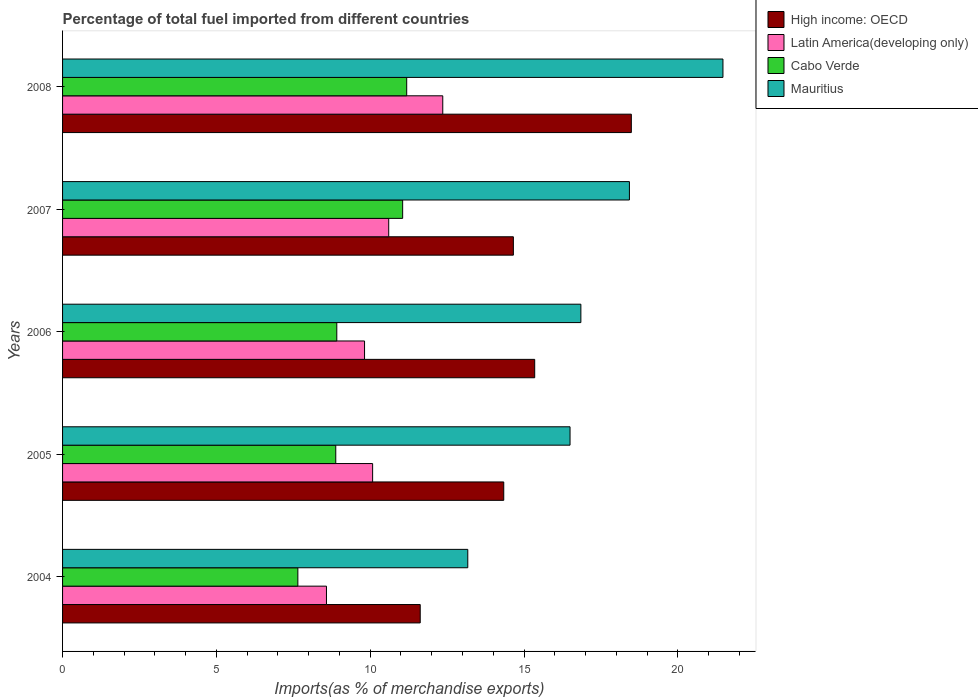How many different coloured bars are there?
Your response must be concise. 4. How many groups of bars are there?
Your response must be concise. 5. Are the number of bars per tick equal to the number of legend labels?
Offer a terse response. Yes. How many bars are there on the 3rd tick from the top?
Keep it short and to the point. 4. How many bars are there on the 1st tick from the bottom?
Your answer should be compact. 4. In how many cases, is the number of bars for a given year not equal to the number of legend labels?
Your answer should be very brief. 0. What is the percentage of imports to different countries in High income: OECD in 2008?
Make the answer very short. 18.49. Across all years, what is the maximum percentage of imports to different countries in Cabo Verde?
Provide a succinct answer. 11.19. Across all years, what is the minimum percentage of imports to different countries in Latin America(developing only)?
Offer a terse response. 8.58. In which year was the percentage of imports to different countries in Mauritius maximum?
Offer a terse response. 2008. What is the total percentage of imports to different countries in Latin America(developing only) in the graph?
Provide a succinct answer. 51.43. What is the difference between the percentage of imports to different countries in High income: OECD in 2006 and that in 2008?
Your answer should be compact. -3.14. What is the difference between the percentage of imports to different countries in Mauritius in 2006 and the percentage of imports to different countries in Cabo Verde in 2005?
Offer a terse response. 7.97. What is the average percentage of imports to different countries in Cabo Verde per year?
Offer a very short reply. 9.54. In the year 2007, what is the difference between the percentage of imports to different countries in High income: OECD and percentage of imports to different countries in Cabo Verde?
Your answer should be very brief. 3.6. What is the ratio of the percentage of imports to different countries in Mauritius in 2004 to that in 2005?
Your response must be concise. 0.8. What is the difference between the highest and the second highest percentage of imports to different countries in High income: OECD?
Provide a short and direct response. 3.14. What is the difference between the highest and the lowest percentage of imports to different countries in Mauritius?
Your answer should be very brief. 8.29. In how many years, is the percentage of imports to different countries in Cabo Verde greater than the average percentage of imports to different countries in Cabo Verde taken over all years?
Provide a short and direct response. 2. Is the sum of the percentage of imports to different countries in Cabo Verde in 2004 and 2007 greater than the maximum percentage of imports to different countries in Latin America(developing only) across all years?
Provide a succinct answer. Yes. Is it the case that in every year, the sum of the percentage of imports to different countries in High income: OECD and percentage of imports to different countries in Mauritius is greater than the sum of percentage of imports to different countries in Latin America(developing only) and percentage of imports to different countries in Cabo Verde?
Provide a short and direct response. Yes. What does the 4th bar from the top in 2006 represents?
Give a very brief answer. High income: OECD. What does the 4th bar from the bottom in 2006 represents?
Provide a short and direct response. Mauritius. How many bars are there?
Ensure brevity in your answer.  20. What is the difference between two consecutive major ticks on the X-axis?
Provide a succinct answer. 5. Are the values on the major ticks of X-axis written in scientific E-notation?
Your response must be concise. No. Does the graph contain any zero values?
Your answer should be very brief. No. Does the graph contain grids?
Keep it short and to the point. No. Where does the legend appear in the graph?
Make the answer very short. Top right. What is the title of the graph?
Your answer should be compact. Percentage of total fuel imported from different countries. What is the label or title of the X-axis?
Your answer should be compact. Imports(as % of merchandise exports). What is the label or title of the Y-axis?
Make the answer very short. Years. What is the Imports(as % of merchandise exports) of High income: OECD in 2004?
Your answer should be very brief. 11.63. What is the Imports(as % of merchandise exports) of Latin America(developing only) in 2004?
Provide a succinct answer. 8.58. What is the Imports(as % of merchandise exports) in Cabo Verde in 2004?
Give a very brief answer. 7.65. What is the Imports(as % of merchandise exports) in Mauritius in 2004?
Keep it short and to the point. 13.17. What is the Imports(as % of merchandise exports) of High income: OECD in 2005?
Your answer should be very brief. 14.34. What is the Imports(as % of merchandise exports) in Latin America(developing only) in 2005?
Provide a short and direct response. 10.08. What is the Imports(as % of merchandise exports) in Cabo Verde in 2005?
Keep it short and to the point. 8.88. What is the Imports(as % of merchandise exports) of Mauritius in 2005?
Your answer should be very brief. 16.5. What is the Imports(as % of merchandise exports) of High income: OECD in 2006?
Your response must be concise. 15.35. What is the Imports(as % of merchandise exports) in Latin America(developing only) in 2006?
Offer a very short reply. 9.82. What is the Imports(as % of merchandise exports) in Cabo Verde in 2006?
Ensure brevity in your answer.  8.91. What is the Imports(as % of merchandise exports) of Mauritius in 2006?
Your answer should be compact. 16.85. What is the Imports(as % of merchandise exports) in High income: OECD in 2007?
Your answer should be compact. 14.65. What is the Imports(as % of merchandise exports) of Latin America(developing only) in 2007?
Provide a short and direct response. 10.6. What is the Imports(as % of merchandise exports) of Cabo Verde in 2007?
Your answer should be very brief. 11.05. What is the Imports(as % of merchandise exports) in Mauritius in 2007?
Give a very brief answer. 18.43. What is the Imports(as % of merchandise exports) in High income: OECD in 2008?
Your answer should be very brief. 18.49. What is the Imports(as % of merchandise exports) of Latin America(developing only) in 2008?
Offer a terse response. 12.36. What is the Imports(as % of merchandise exports) in Cabo Verde in 2008?
Your answer should be compact. 11.19. What is the Imports(as % of merchandise exports) of Mauritius in 2008?
Provide a succinct answer. 21.47. Across all years, what is the maximum Imports(as % of merchandise exports) in High income: OECD?
Your answer should be compact. 18.49. Across all years, what is the maximum Imports(as % of merchandise exports) in Latin America(developing only)?
Ensure brevity in your answer.  12.36. Across all years, what is the maximum Imports(as % of merchandise exports) in Cabo Verde?
Offer a terse response. 11.19. Across all years, what is the maximum Imports(as % of merchandise exports) in Mauritius?
Provide a succinct answer. 21.47. Across all years, what is the minimum Imports(as % of merchandise exports) of High income: OECD?
Your answer should be compact. 11.63. Across all years, what is the minimum Imports(as % of merchandise exports) of Latin America(developing only)?
Provide a succinct answer. 8.58. Across all years, what is the minimum Imports(as % of merchandise exports) of Cabo Verde?
Make the answer very short. 7.65. Across all years, what is the minimum Imports(as % of merchandise exports) in Mauritius?
Give a very brief answer. 13.17. What is the total Imports(as % of merchandise exports) in High income: OECD in the graph?
Offer a terse response. 74.45. What is the total Imports(as % of merchandise exports) of Latin America(developing only) in the graph?
Your answer should be very brief. 51.43. What is the total Imports(as % of merchandise exports) in Cabo Verde in the graph?
Offer a terse response. 47.68. What is the total Imports(as % of merchandise exports) of Mauritius in the graph?
Offer a very short reply. 86.41. What is the difference between the Imports(as % of merchandise exports) of High income: OECD in 2004 and that in 2005?
Ensure brevity in your answer.  -2.71. What is the difference between the Imports(as % of merchandise exports) of Latin America(developing only) in 2004 and that in 2005?
Ensure brevity in your answer.  -1.5. What is the difference between the Imports(as % of merchandise exports) of Cabo Verde in 2004 and that in 2005?
Your answer should be compact. -1.23. What is the difference between the Imports(as % of merchandise exports) in Mauritius in 2004 and that in 2005?
Ensure brevity in your answer.  -3.32. What is the difference between the Imports(as % of merchandise exports) of High income: OECD in 2004 and that in 2006?
Offer a terse response. -3.72. What is the difference between the Imports(as % of merchandise exports) in Latin America(developing only) in 2004 and that in 2006?
Offer a very short reply. -1.24. What is the difference between the Imports(as % of merchandise exports) in Cabo Verde in 2004 and that in 2006?
Make the answer very short. -1.27. What is the difference between the Imports(as % of merchandise exports) in Mauritius in 2004 and that in 2006?
Your answer should be compact. -3.68. What is the difference between the Imports(as % of merchandise exports) in High income: OECD in 2004 and that in 2007?
Provide a succinct answer. -3.03. What is the difference between the Imports(as % of merchandise exports) in Latin America(developing only) in 2004 and that in 2007?
Provide a short and direct response. -2.02. What is the difference between the Imports(as % of merchandise exports) in Cabo Verde in 2004 and that in 2007?
Offer a terse response. -3.41. What is the difference between the Imports(as % of merchandise exports) of Mauritius in 2004 and that in 2007?
Your answer should be very brief. -5.25. What is the difference between the Imports(as % of merchandise exports) of High income: OECD in 2004 and that in 2008?
Offer a very short reply. -6.86. What is the difference between the Imports(as % of merchandise exports) of Latin America(developing only) in 2004 and that in 2008?
Provide a succinct answer. -3.78. What is the difference between the Imports(as % of merchandise exports) in Cabo Verde in 2004 and that in 2008?
Keep it short and to the point. -3.54. What is the difference between the Imports(as % of merchandise exports) in Mauritius in 2004 and that in 2008?
Make the answer very short. -8.29. What is the difference between the Imports(as % of merchandise exports) in High income: OECD in 2005 and that in 2006?
Give a very brief answer. -1.01. What is the difference between the Imports(as % of merchandise exports) in Latin America(developing only) in 2005 and that in 2006?
Offer a terse response. 0.26. What is the difference between the Imports(as % of merchandise exports) in Cabo Verde in 2005 and that in 2006?
Make the answer very short. -0.03. What is the difference between the Imports(as % of merchandise exports) of Mauritius in 2005 and that in 2006?
Give a very brief answer. -0.35. What is the difference between the Imports(as % of merchandise exports) in High income: OECD in 2005 and that in 2007?
Provide a succinct answer. -0.31. What is the difference between the Imports(as % of merchandise exports) of Latin America(developing only) in 2005 and that in 2007?
Your answer should be compact. -0.52. What is the difference between the Imports(as % of merchandise exports) in Cabo Verde in 2005 and that in 2007?
Your answer should be very brief. -2.17. What is the difference between the Imports(as % of merchandise exports) in Mauritius in 2005 and that in 2007?
Provide a succinct answer. -1.93. What is the difference between the Imports(as % of merchandise exports) in High income: OECD in 2005 and that in 2008?
Give a very brief answer. -4.15. What is the difference between the Imports(as % of merchandise exports) in Latin America(developing only) in 2005 and that in 2008?
Provide a succinct answer. -2.28. What is the difference between the Imports(as % of merchandise exports) in Cabo Verde in 2005 and that in 2008?
Ensure brevity in your answer.  -2.31. What is the difference between the Imports(as % of merchandise exports) in Mauritius in 2005 and that in 2008?
Give a very brief answer. -4.97. What is the difference between the Imports(as % of merchandise exports) of High income: OECD in 2006 and that in 2007?
Offer a very short reply. 0.69. What is the difference between the Imports(as % of merchandise exports) of Latin America(developing only) in 2006 and that in 2007?
Offer a very short reply. -0.79. What is the difference between the Imports(as % of merchandise exports) of Cabo Verde in 2006 and that in 2007?
Give a very brief answer. -2.14. What is the difference between the Imports(as % of merchandise exports) in Mauritius in 2006 and that in 2007?
Make the answer very short. -1.58. What is the difference between the Imports(as % of merchandise exports) of High income: OECD in 2006 and that in 2008?
Provide a succinct answer. -3.14. What is the difference between the Imports(as % of merchandise exports) of Latin America(developing only) in 2006 and that in 2008?
Your answer should be compact. -2.54. What is the difference between the Imports(as % of merchandise exports) in Cabo Verde in 2006 and that in 2008?
Make the answer very short. -2.27. What is the difference between the Imports(as % of merchandise exports) of Mauritius in 2006 and that in 2008?
Make the answer very short. -4.62. What is the difference between the Imports(as % of merchandise exports) in High income: OECD in 2007 and that in 2008?
Provide a succinct answer. -3.83. What is the difference between the Imports(as % of merchandise exports) in Latin America(developing only) in 2007 and that in 2008?
Your answer should be compact. -1.76. What is the difference between the Imports(as % of merchandise exports) in Cabo Verde in 2007 and that in 2008?
Offer a terse response. -0.13. What is the difference between the Imports(as % of merchandise exports) in Mauritius in 2007 and that in 2008?
Provide a short and direct response. -3.04. What is the difference between the Imports(as % of merchandise exports) in High income: OECD in 2004 and the Imports(as % of merchandise exports) in Latin America(developing only) in 2005?
Give a very brief answer. 1.55. What is the difference between the Imports(as % of merchandise exports) of High income: OECD in 2004 and the Imports(as % of merchandise exports) of Cabo Verde in 2005?
Provide a succinct answer. 2.75. What is the difference between the Imports(as % of merchandise exports) of High income: OECD in 2004 and the Imports(as % of merchandise exports) of Mauritius in 2005?
Offer a very short reply. -4.87. What is the difference between the Imports(as % of merchandise exports) in Latin America(developing only) in 2004 and the Imports(as % of merchandise exports) in Cabo Verde in 2005?
Ensure brevity in your answer.  -0.3. What is the difference between the Imports(as % of merchandise exports) of Latin America(developing only) in 2004 and the Imports(as % of merchandise exports) of Mauritius in 2005?
Your answer should be very brief. -7.92. What is the difference between the Imports(as % of merchandise exports) of Cabo Verde in 2004 and the Imports(as % of merchandise exports) of Mauritius in 2005?
Your answer should be very brief. -8.85. What is the difference between the Imports(as % of merchandise exports) in High income: OECD in 2004 and the Imports(as % of merchandise exports) in Latin America(developing only) in 2006?
Ensure brevity in your answer.  1.81. What is the difference between the Imports(as % of merchandise exports) of High income: OECD in 2004 and the Imports(as % of merchandise exports) of Cabo Verde in 2006?
Offer a terse response. 2.71. What is the difference between the Imports(as % of merchandise exports) of High income: OECD in 2004 and the Imports(as % of merchandise exports) of Mauritius in 2006?
Your answer should be compact. -5.22. What is the difference between the Imports(as % of merchandise exports) in Latin America(developing only) in 2004 and the Imports(as % of merchandise exports) in Cabo Verde in 2006?
Your answer should be very brief. -0.34. What is the difference between the Imports(as % of merchandise exports) of Latin America(developing only) in 2004 and the Imports(as % of merchandise exports) of Mauritius in 2006?
Your answer should be very brief. -8.27. What is the difference between the Imports(as % of merchandise exports) of Cabo Verde in 2004 and the Imports(as % of merchandise exports) of Mauritius in 2006?
Ensure brevity in your answer.  -9.2. What is the difference between the Imports(as % of merchandise exports) in High income: OECD in 2004 and the Imports(as % of merchandise exports) in Latin America(developing only) in 2007?
Your answer should be compact. 1.02. What is the difference between the Imports(as % of merchandise exports) of High income: OECD in 2004 and the Imports(as % of merchandise exports) of Cabo Verde in 2007?
Ensure brevity in your answer.  0.57. What is the difference between the Imports(as % of merchandise exports) of High income: OECD in 2004 and the Imports(as % of merchandise exports) of Mauritius in 2007?
Your answer should be compact. -6.8. What is the difference between the Imports(as % of merchandise exports) of Latin America(developing only) in 2004 and the Imports(as % of merchandise exports) of Cabo Verde in 2007?
Offer a terse response. -2.48. What is the difference between the Imports(as % of merchandise exports) in Latin America(developing only) in 2004 and the Imports(as % of merchandise exports) in Mauritius in 2007?
Provide a short and direct response. -9.85. What is the difference between the Imports(as % of merchandise exports) in Cabo Verde in 2004 and the Imports(as % of merchandise exports) in Mauritius in 2007?
Keep it short and to the point. -10.78. What is the difference between the Imports(as % of merchandise exports) in High income: OECD in 2004 and the Imports(as % of merchandise exports) in Latin America(developing only) in 2008?
Ensure brevity in your answer.  -0.73. What is the difference between the Imports(as % of merchandise exports) of High income: OECD in 2004 and the Imports(as % of merchandise exports) of Cabo Verde in 2008?
Offer a terse response. 0.44. What is the difference between the Imports(as % of merchandise exports) in High income: OECD in 2004 and the Imports(as % of merchandise exports) in Mauritius in 2008?
Ensure brevity in your answer.  -9.84. What is the difference between the Imports(as % of merchandise exports) of Latin America(developing only) in 2004 and the Imports(as % of merchandise exports) of Cabo Verde in 2008?
Keep it short and to the point. -2.61. What is the difference between the Imports(as % of merchandise exports) of Latin America(developing only) in 2004 and the Imports(as % of merchandise exports) of Mauritius in 2008?
Your response must be concise. -12.89. What is the difference between the Imports(as % of merchandise exports) in Cabo Verde in 2004 and the Imports(as % of merchandise exports) in Mauritius in 2008?
Provide a succinct answer. -13.82. What is the difference between the Imports(as % of merchandise exports) of High income: OECD in 2005 and the Imports(as % of merchandise exports) of Latin America(developing only) in 2006?
Offer a terse response. 4.52. What is the difference between the Imports(as % of merchandise exports) in High income: OECD in 2005 and the Imports(as % of merchandise exports) in Cabo Verde in 2006?
Your answer should be compact. 5.43. What is the difference between the Imports(as % of merchandise exports) of High income: OECD in 2005 and the Imports(as % of merchandise exports) of Mauritius in 2006?
Keep it short and to the point. -2.51. What is the difference between the Imports(as % of merchandise exports) of Latin America(developing only) in 2005 and the Imports(as % of merchandise exports) of Cabo Verde in 2006?
Provide a succinct answer. 1.16. What is the difference between the Imports(as % of merchandise exports) of Latin America(developing only) in 2005 and the Imports(as % of merchandise exports) of Mauritius in 2006?
Keep it short and to the point. -6.77. What is the difference between the Imports(as % of merchandise exports) in Cabo Verde in 2005 and the Imports(as % of merchandise exports) in Mauritius in 2006?
Your response must be concise. -7.97. What is the difference between the Imports(as % of merchandise exports) of High income: OECD in 2005 and the Imports(as % of merchandise exports) of Latin America(developing only) in 2007?
Your response must be concise. 3.74. What is the difference between the Imports(as % of merchandise exports) of High income: OECD in 2005 and the Imports(as % of merchandise exports) of Cabo Verde in 2007?
Offer a terse response. 3.29. What is the difference between the Imports(as % of merchandise exports) of High income: OECD in 2005 and the Imports(as % of merchandise exports) of Mauritius in 2007?
Keep it short and to the point. -4.08. What is the difference between the Imports(as % of merchandise exports) of Latin America(developing only) in 2005 and the Imports(as % of merchandise exports) of Cabo Verde in 2007?
Offer a terse response. -0.98. What is the difference between the Imports(as % of merchandise exports) in Latin America(developing only) in 2005 and the Imports(as % of merchandise exports) in Mauritius in 2007?
Ensure brevity in your answer.  -8.35. What is the difference between the Imports(as % of merchandise exports) in Cabo Verde in 2005 and the Imports(as % of merchandise exports) in Mauritius in 2007?
Your answer should be compact. -9.55. What is the difference between the Imports(as % of merchandise exports) in High income: OECD in 2005 and the Imports(as % of merchandise exports) in Latin America(developing only) in 2008?
Offer a terse response. 1.98. What is the difference between the Imports(as % of merchandise exports) in High income: OECD in 2005 and the Imports(as % of merchandise exports) in Cabo Verde in 2008?
Your response must be concise. 3.15. What is the difference between the Imports(as % of merchandise exports) in High income: OECD in 2005 and the Imports(as % of merchandise exports) in Mauritius in 2008?
Your answer should be compact. -7.13. What is the difference between the Imports(as % of merchandise exports) in Latin America(developing only) in 2005 and the Imports(as % of merchandise exports) in Cabo Verde in 2008?
Your response must be concise. -1.11. What is the difference between the Imports(as % of merchandise exports) of Latin America(developing only) in 2005 and the Imports(as % of merchandise exports) of Mauritius in 2008?
Offer a terse response. -11.39. What is the difference between the Imports(as % of merchandise exports) in Cabo Verde in 2005 and the Imports(as % of merchandise exports) in Mauritius in 2008?
Provide a succinct answer. -12.59. What is the difference between the Imports(as % of merchandise exports) of High income: OECD in 2006 and the Imports(as % of merchandise exports) of Latin America(developing only) in 2007?
Provide a succinct answer. 4.75. What is the difference between the Imports(as % of merchandise exports) of High income: OECD in 2006 and the Imports(as % of merchandise exports) of Cabo Verde in 2007?
Offer a terse response. 4.29. What is the difference between the Imports(as % of merchandise exports) of High income: OECD in 2006 and the Imports(as % of merchandise exports) of Mauritius in 2007?
Ensure brevity in your answer.  -3.08. What is the difference between the Imports(as % of merchandise exports) of Latin America(developing only) in 2006 and the Imports(as % of merchandise exports) of Cabo Verde in 2007?
Offer a very short reply. -1.24. What is the difference between the Imports(as % of merchandise exports) of Latin America(developing only) in 2006 and the Imports(as % of merchandise exports) of Mauritius in 2007?
Provide a short and direct response. -8.61. What is the difference between the Imports(as % of merchandise exports) in Cabo Verde in 2006 and the Imports(as % of merchandise exports) in Mauritius in 2007?
Provide a short and direct response. -9.51. What is the difference between the Imports(as % of merchandise exports) of High income: OECD in 2006 and the Imports(as % of merchandise exports) of Latin America(developing only) in 2008?
Your answer should be very brief. 2.99. What is the difference between the Imports(as % of merchandise exports) of High income: OECD in 2006 and the Imports(as % of merchandise exports) of Cabo Verde in 2008?
Ensure brevity in your answer.  4.16. What is the difference between the Imports(as % of merchandise exports) of High income: OECD in 2006 and the Imports(as % of merchandise exports) of Mauritius in 2008?
Offer a very short reply. -6.12. What is the difference between the Imports(as % of merchandise exports) of Latin America(developing only) in 2006 and the Imports(as % of merchandise exports) of Cabo Verde in 2008?
Your answer should be compact. -1.37. What is the difference between the Imports(as % of merchandise exports) of Latin America(developing only) in 2006 and the Imports(as % of merchandise exports) of Mauritius in 2008?
Your response must be concise. -11.65. What is the difference between the Imports(as % of merchandise exports) in Cabo Verde in 2006 and the Imports(as % of merchandise exports) in Mauritius in 2008?
Provide a succinct answer. -12.55. What is the difference between the Imports(as % of merchandise exports) in High income: OECD in 2007 and the Imports(as % of merchandise exports) in Latin America(developing only) in 2008?
Provide a succinct answer. 2.3. What is the difference between the Imports(as % of merchandise exports) in High income: OECD in 2007 and the Imports(as % of merchandise exports) in Cabo Verde in 2008?
Offer a terse response. 3.47. What is the difference between the Imports(as % of merchandise exports) in High income: OECD in 2007 and the Imports(as % of merchandise exports) in Mauritius in 2008?
Keep it short and to the point. -6.81. What is the difference between the Imports(as % of merchandise exports) in Latin America(developing only) in 2007 and the Imports(as % of merchandise exports) in Cabo Verde in 2008?
Provide a short and direct response. -0.58. What is the difference between the Imports(as % of merchandise exports) in Latin America(developing only) in 2007 and the Imports(as % of merchandise exports) in Mauritius in 2008?
Ensure brevity in your answer.  -10.86. What is the difference between the Imports(as % of merchandise exports) in Cabo Verde in 2007 and the Imports(as % of merchandise exports) in Mauritius in 2008?
Offer a terse response. -10.41. What is the average Imports(as % of merchandise exports) of High income: OECD per year?
Keep it short and to the point. 14.89. What is the average Imports(as % of merchandise exports) of Latin America(developing only) per year?
Provide a succinct answer. 10.29. What is the average Imports(as % of merchandise exports) in Cabo Verde per year?
Provide a succinct answer. 9.54. What is the average Imports(as % of merchandise exports) of Mauritius per year?
Keep it short and to the point. 17.28. In the year 2004, what is the difference between the Imports(as % of merchandise exports) in High income: OECD and Imports(as % of merchandise exports) in Latin America(developing only)?
Give a very brief answer. 3.05. In the year 2004, what is the difference between the Imports(as % of merchandise exports) of High income: OECD and Imports(as % of merchandise exports) of Cabo Verde?
Provide a succinct answer. 3.98. In the year 2004, what is the difference between the Imports(as % of merchandise exports) of High income: OECD and Imports(as % of merchandise exports) of Mauritius?
Provide a short and direct response. -1.55. In the year 2004, what is the difference between the Imports(as % of merchandise exports) of Latin America(developing only) and Imports(as % of merchandise exports) of Cabo Verde?
Make the answer very short. 0.93. In the year 2004, what is the difference between the Imports(as % of merchandise exports) in Latin America(developing only) and Imports(as % of merchandise exports) in Mauritius?
Your answer should be very brief. -4.59. In the year 2004, what is the difference between the Imports(as % of merchandise exports) in Cabo Verde and Imports(as % of merchandise exports) in Mauritius?
Ensure brevity in your answer.  -5.52. In the year 2005, what is the difference between the Imports(as % of merchandise exports) in High income: OECD and Imports(as % of merchandise exports) in Latin America(developing only)?
Provide a succinct answer. 4.26. In the year 2005, what is the difference between the Imports(as % of merchandise exports) of High income: OECD and Imports(as % of merchandise exports) of Cabo Verde?
Offer a terse response. 5.46. In the year 2005, what is the difference between the Imports(as % of merchandise exports) of High income: OECD and Imports(as % of merchandise exports) of Mauritius?
Give a very brief answer. -2.15. In the year 2005, what is the difference between the Imports(as % of merchandise exports) in Latin America(developing only) and Imports(as % of merchandise exports) in Cabo Verde?
Offer a terse response. 1.2. In the year 2005, what is the difference between the Imports(as % of merchandise exports) in Latin America(developing only) and Imports(as % of merchandise exports) in Mauritius?
Your response must be concise. -6.42. In the year 2005, what is the difference between the Imports(as % of merchandise exports) in Cabo Verde and Imports(as % of merchandise exports) in Mauritius?
Make the answer very short. -7.62. In the year 2006, what is the difference between the Imports(as % of merchandise exports) in High income: OECD and Imports(as % of merchandise exports) in Latin America(developing only)?
Offer a very short reply. 5.53. In the year 2006, what is the difference between the Imports(as % of merchandise exports) in High income: OECD and Imports(as % of merchandise exports) in Cabo Verde?
Provide a short and direct response. 6.43. In the year 2006, what is the difference between the Imports(as % of merchandise exports) of High income: OECD and Imports(as % of merchandise exports) of Mauritius?
Provide a succinct answer. -1.5. In the year 2006, what is the difference between the Imports(as % of merchandise exports) in Latin America(developing only) and Imports(as % of merchandise exports) in Cabo Verde?
Ensure brevity in your answer.  0.9. In the year 2006, what is the difference between the Imports(as % of merchandise exports) of Latin America(developing only) and Imports(as % of merchandise exports) of Mauritius?
Your answer should be compact. -7.03. In the year 2006, what is the difference between the Imports(as % of merchandise exports) of Cabo Verde and Imports(as % of merchandise exports) of Mauritius?
Offer a terse response. -7.93. In the year 2007, what is the difference between the Imports(as % of merchandise exports) in High income: OECD and Imports(as % of merchandise exports) in Latin America(developing only)?
Give a very brief answer. 4.05. In the year 2007, what is the difference between the Imports(as % of merchandise exports) of High income: OECD and Imports(as % of merchandise exports) of Cabo Verde?
Your response must be concise. 3.6. In the year 2007, what is the difference between the Imports(as % of merchandise exports) in High income: OECD and Imports(as % of merchandise exports) in Mauritius?
Your answer should be compact. -3.77. In the year 2007, what is the difference between the Imports(as % of merchandise exports) of Latin America(developing only) and Imports(as % of merchandise exports) of Cabo Verde?
Your answer should be very brief. -0.45. In the year 2007, what is the difference between the Imports(as % of merchandise exports) in Latin America(developing only) and Imports(as % of merchandise exports) in Mauritius?
Offer a terse response. -7.82. In the year 2007, what is the difference between the Imports(as % of merchandise exports) of Cabo Verde and Imports(as % of merchandise exports) of Mauritius?
Offer a very short reply. -7.37. In the year 2008, what is the difference between the Imports(as % of merchandise exports) in High income: OECD and Imports(as % of merchandise exports) in Latin America(developing only)?
Provide a succinct answer. 6.13. In the year 2008, what is the difference between the Imports(as % of merchandise exports) in High income: OECD and Imports(as % of merchandise exports) in Cabo Verde?
Your answer should be compact. 7.3. In the year 2008, what is the difference between the Imports(as % of merchandise exports) in High income: OECD and Imports(as % of merchandise exports) in Mauritius?
Your answer should be compact. -2.98. In the year 2008, what is the difference between the Imports(as % of merchandise exports) in Latin America(developing only) and Imports(as % of merchandise exports) in Cabo Verde?
Provide a short and direct response. 1.17. In the year 2008, what is the difference between the Imports(as % of merchandise exports) in Latin America(developing only) and Imports(as % of merchandise exports) in Mauritius?
Provide a succinct answer. -9.11. In the year 2008, what is the difference between the Imports(as % of merchandise exports) in Cabo Verde and Imports(as % of merchandise exports) in Mauritius?
Your answer should be compact. -10.28. What is the ratio of the Imports(as % of merchandise exports) of High income: OECD in 2004 to that in 2005?
Give a very brief answer. 0.81. What is the ratio of the Imports(as % of merchandise exports) in Latin America(developing only) in 2004 to that in 2005?
Provide a short and direct response. 0.85. What is the ratio of the Imports(as % of merchandise exports) in Cabo Verde in 2004 to that in 2005?
Your answer should be compact. 0.86. What is the ratio of the Imports(as % of merchandise exports) in Mauritius in 2004 to that in 2005?
Make the answer very short. 0.8. What is the ratio of the Imports(as % of merchandise exports) in High income: OECD in 2004 to that in 2006?
Offer a very short reply. 0.76. What is the ratio of the Imports(as % of merchandise exports) of Latin America(developing only) in 2004 to that in 2006?
Make the answer very short. 0.87. What is the ratio of the Imports(as % of merchandise exports) of Cabo Verde in 2004 to that in 2006?
Your answer should be very brief. 0.86. What is the ratio of the Imports(as % of merchandise exports) of Mauritius in 2004 to that in 2006?
Offer a very short reply. 0.78. What is the ratio of the Imports(as % of merchandise exports) in High income: OECD in 2004 to that in 2007?
Your answer should be compact. 0.79. What is the ratio of the Imports(as % of merchandise exports) of Latin America(developing only) in 2004 to that in 2007?
Offer a terse response. 0.81. What is the ratio of the Imports(as % of merchandise exports) in Cabo Verde in 2004 to that in 2007?
Make the answer very short. 0.69. What is the ratio of the Imports(as % of merchandise exports) in Mauritius in 2004 to that in 2007?
Your response must be concise. 0.71. What is the ratio of the Imports(as % of merchandise exports) of High income: OECD in 2004 to that in 2008?
Your response must be concise. 0.63. What is the ratio of the Imports(as % of merchandise exports) of Latin America(developing only) in 2004 to that in 2008?
Your response must be concise. 0.69. What is the ratio of the Imports(as % of merchandise exports) in Cabo Verde in 2004 to that in 2008?
Offer a very short reply. 0.68. What is the ratio of the Imports(as % of merchandise exports) of Mauritius in 2004 to that in 2008?
Make the answer very short. 0.61. What is the ratio of the Imports(as % of merchandise exports) in High income: OECD in 2005 to that in 2006?
Offer a very short reply. 0.93. What is the ratio of the Imports(as % of merchandise exports) in Latin America(developing only) in 2005 to that in 2006?
Offer a terse response. 1.03. What is the ratio of the Imports(as % of merchandise exports) in Mauritius in 2005 to that in 2006?
Offer a very short reply. 0.98. What is the ratio of the Imports(as % of merchandise exports) of High income: OECD in 2005 to that in 2007?
Make the answer very short. 0.98. What is the ratio of the Imports(as % of merchandise exports) of Latin America(developing only) in 2005 to that in 2007?
Give a very brief answer. 0.95. What is the ratio of the Imports(as % of merchandise exports) in Cabo Verde in 2005 to that in 2007?
Ensure brevity in your answer.  0.8. What is the ratio of the Imports(as % of merchandise exports) in Mauritius in 2005 to that in 2007?
Your answer should be compact. 0.9. What is the ratio of the Imports(as % of merchandise exports) of High income: OECD in 2005 to that in 2008?
Your answer should be compact. 0.78. What is the ratio of the Imports(as % of merchandise exports) in Latin America(developing only) in 2005 to that in 2008?
Your answer should be compact. 0.82. What is the ratio of the Imports(as % of merchandise exports) in Cabo Verde in 2005 to that in 2008?
Provide a short and direct response. 0.79. What is the ratio of the Imports(as % of merchandise exports) of Mauritius in 2005 to that in 2008?
Offer a terse response. 0.77. What is the ratio of the Imports(as % of merchandise exports) of High income: OECD in 2006 to that in 2007?
Make the answer very short. 1.05. What is the ratio of the Imports(as % of merchandise exports) in Latin America(developing only) in 2006 to that in 2007?
Offer a terse response. 0.93. What is the ratio of the Imports(as % of merchandise exports) in Cabo Verde in 2006 to that in 2007?
Provide a short and direct response. 0.81. What is the ratio of the Imports(as % of merchandise exports) in Mauritius in 2006 to that in 2007?
Keep it short and to the point. 0.91. What is the ratio of the Imports(as % of merchandise exports) of High income: OECD in 2006 to that in 2008?
Your answer should be compact. 0.83. What is the ratio of the Imports(as % of merchandise exports) of Latin America(developing only) in 2006 to that in 2008?
Keep it short and to the point. 0.79. What is the ratio of the Imports(as % of merchandise exports) in Cabo Verde in 2006 to that in 2008?
Your response must be concise. 0.8. What is the ratio of the Imports(as % of merchandise exports) of Mauritius in 2006 to that in 2008?
Offer a very short reply. 0.78. What is the ratio of the Imports(as % of merchandise exports) of High income: OECD in 2007 to that in 2008?
Keep it short and to the point. 0.79. What is the ratio of the Imports(as % of merchandise exports) in Latin America(developing only) in 2007 to that in 2008?
Ensure brevity in your answer.  0.86. What is the ratio of the Imports(as % of merchandise exports) in Cabo Verde in 2007 to that in 2008?
Keep it short and to the point. 0.99. What is the ratio of the Imports(as % of merchandise exports) of Mauritius in 2007 to that in 2008?
Your answer should be very brief. 0.86. What is the difference between the highest and the second highest Imports(as % of merchandise exports) of High income: OECD?
Your answer should be very brief. 3.14. What is the difference between the highest and the second highest Imports(as % of merchandise exports) in Latin America(developing only)?
Your response must be concise. 1.76. What is the difference between the highest and the second highest Imports(as % of merchandise exports) in Cabo Verde?
Your answer should be very brief. 0.13. What is the difference between the highest and the second highest Imports(as % of merchandise exports) of Mauritius?
Give a very brief answer. 3.04. What is the difference between the highest and the lowest Imports(as % of merchandise exports) of High income: OECD?
Your response must be concise. 6.86. What is the difference between the highest and the lowest Imports(as % of merchandise exports) of Latin America(developing only)?
Ensure brevity in your answer.  3.78. What is the difference between the highest and the lowest Imports(as % of merchandise exports) of Cabo Verde?
Ensure brevity in your answer.  3.54. What is the difference between the highest and the lowest Imports(as % of merchandise exports) of Mauritius?
Make the answer very short. 8.29. 